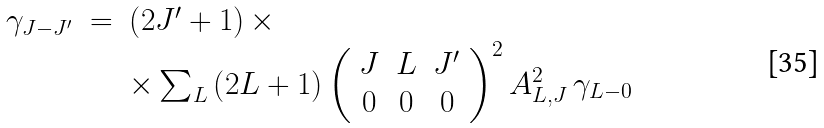<formula> <loc_0><loc_0><loc_500><loc_500>\begin{array} { l l l } \gamma _ { J - J ^ { \prime } } & = & \left ( 2 J ^ { \prime } + 1 \right ) \times \\ & & \times \sum _ { L } \left ( 2 L + 1 \right ) \left ( \begin{array} { c c c } J & L & J ^ { \prime } \\ 0 & 0 & 0 \end{array} \right ) ^ { 2 } A _ { L , J } ^ { 2 } \, \gamma _ { L - 0 } \end{array}</formula> 